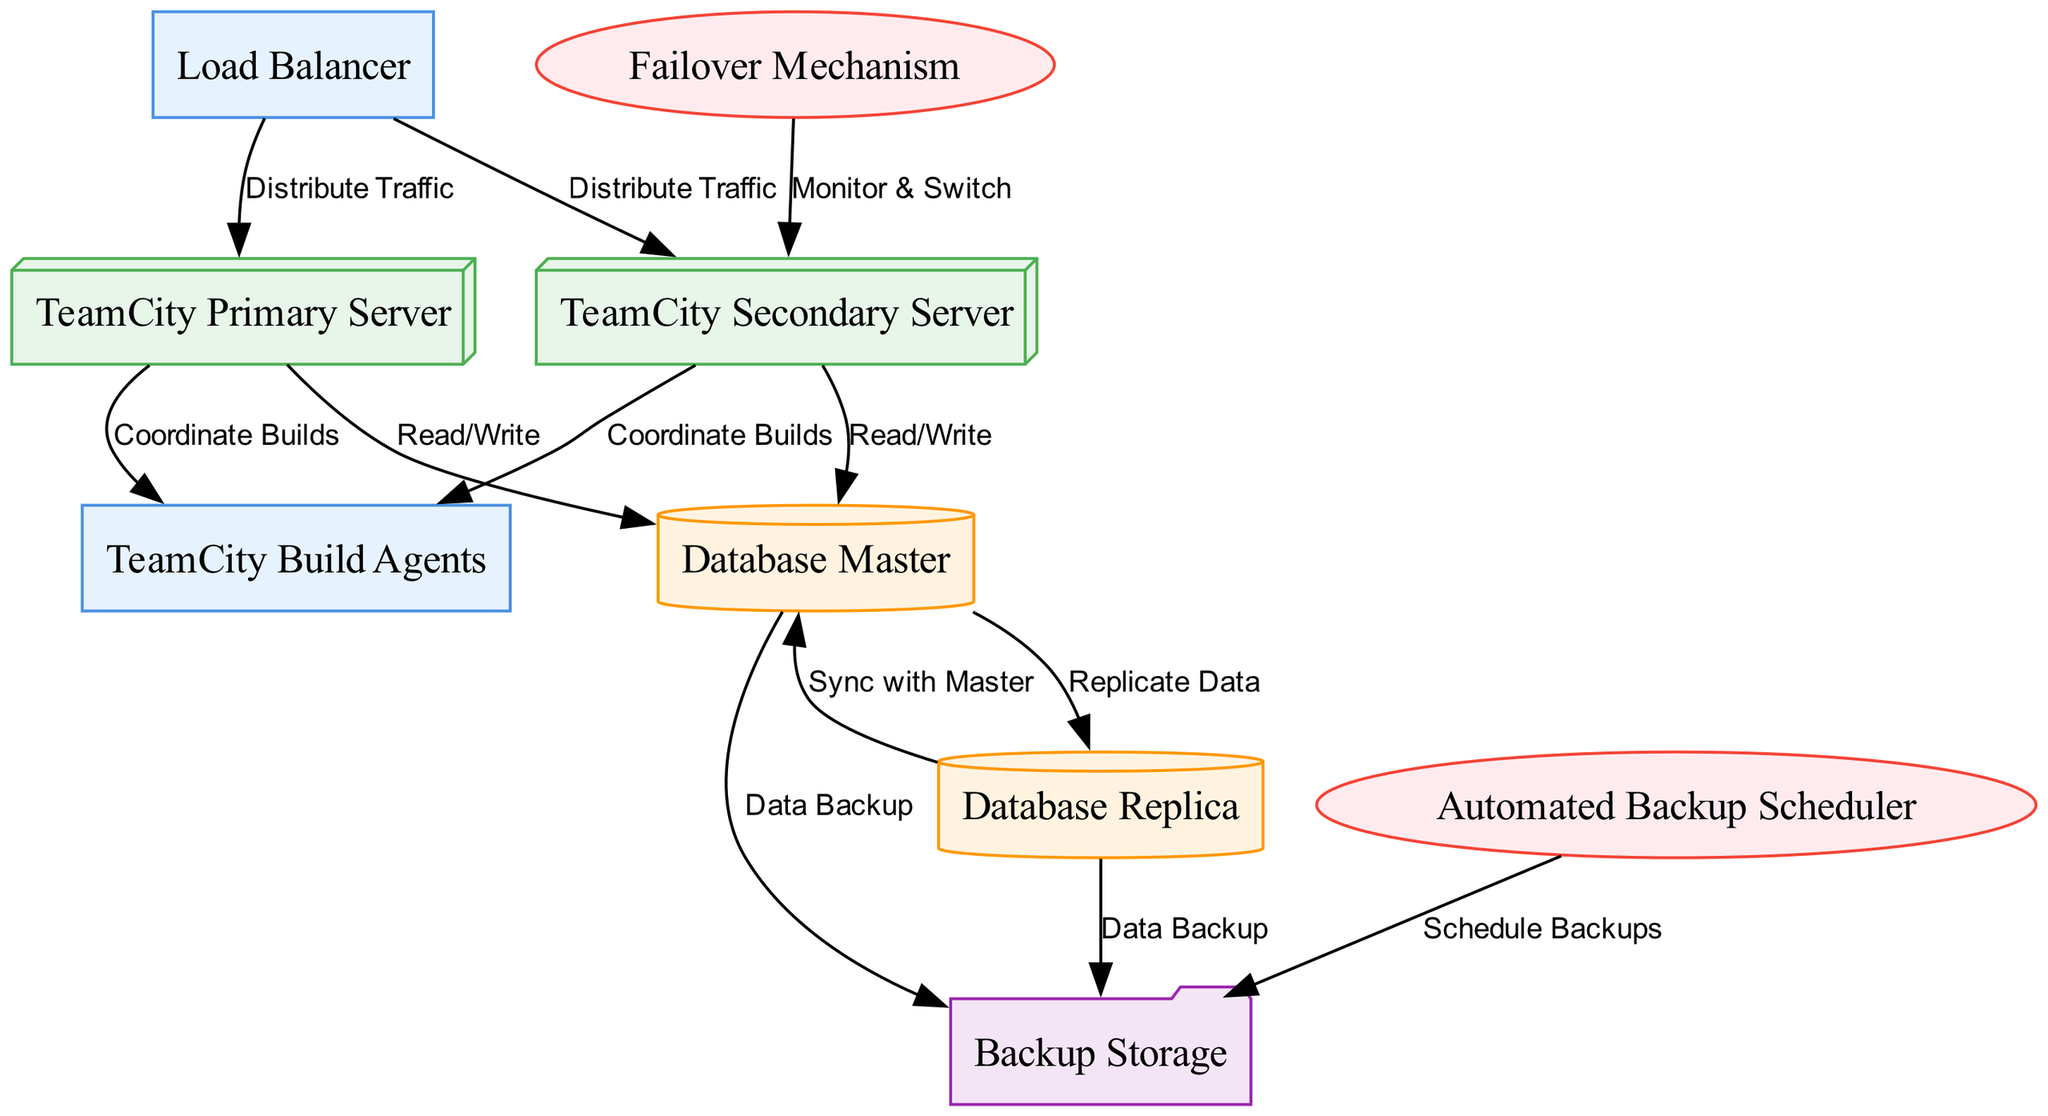What is the primary server in the diagram? In the diagram, the node labeled "TeamCity Primary Server" represents the primary server responsible for handling requests. This can be easily identified as it is mentioned specifically within the list of nodes.
Answer: TeamCity Primary Server How many nodes are there in total? The diagram lists a total of nine distinct nodes including components, servers, databases, storage, and services. This is obtained by counting the items in the list of nodes provided in the data.
Answer: 9 What task is the Load Balancer responsible for? The "Load Balancer" node is responsible for distributing traffic, as indicated by the edge connection labeling "Distribute Traffic" directed towards both the primary and secondary servers. This functionality is essential for ensuring availability and balancing the workload.
Answer: Distribute Traffic How does the Database Master relate to the Backup Storage? The "Database Master" has a direct relationship with "Backup Storage" through the edge labeled "Data Backup," which indicates that the master database backs up data to the storage system. This shows the connection between data handling and the backup system.
Answer: Data Backup What is the function of the Automated Backup Scheduler? The "Automated Backup Scheduler" is represented as a service that schedules backups to the "Backup Storage,” thereby ensuring that regular data backups occur without manual intervention, as shown by the edge connecting these two nodes.
Answer: Schedule Backups How many servers are depicted in the diagram? There are two server nodes shown: "TeamCity Primary Server" and "TeamCity Secondary Server." By reviewing the list of nodes and identifying the server-specific labels, we can confirm there are precisely two servers.
Answer: 2 What mechanism is used to switch to the secondary server? The switch to the secondary server is managed by the "Failover Mechanism," which monitors the primary server's status and operates the switch as needed, a function delineated by the edge leading from the failover service to the secondary server.
Answer: Monitor & Switch How does the Database Replica ensure data consistency? The "Database Replica" node ensures data consistency by having an edge labeled "Sync with Master" that indicates a continual synchronization process with the master database, allowing for up-to-date data availability even in the event of a failure.
Answer: Sync with Master 